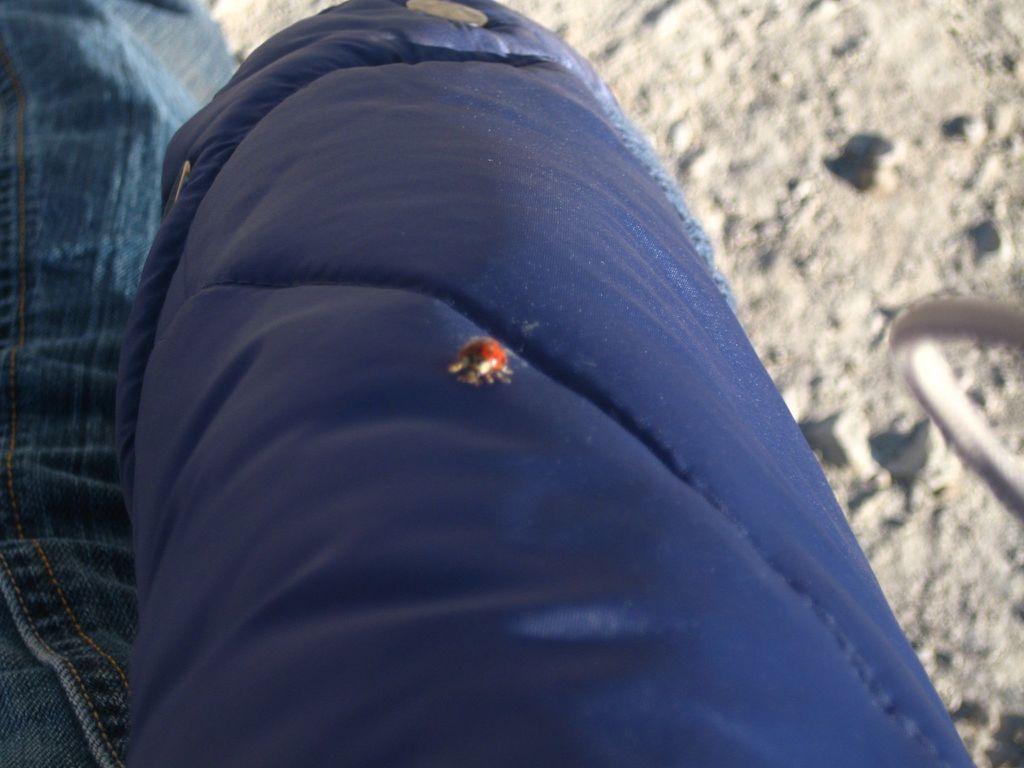Please provide a concise description of this image. There is a blue color thing, on that there is a red color bug. On the left side there is jeans material. In the back it is blurred. 